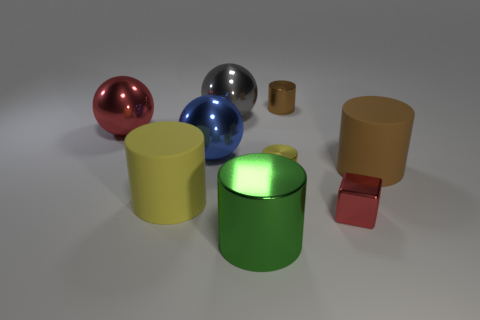Is there anything else that has the same shape as the tiny red metal object?
Provide a succinct answer. No. There is a brown matte object; is its size the same as the red metal thing on the right side of the big green shiny cylinder?
Keep it short and to the point. No. What number of large red balls have the same material as the green thing?
Your answer should be compact. 1. Does the gray object have the same size as the blue sphere?
Give a very brief answer. Yes. Is there any other thing that has the same color as the metal block?
Your response must be concise. Yes. What shape is the large object that is in front of the brown rubber object and behind the green cylinder?
Your answer should be compact. Cylinder. There is a brown cylinder that is behind the big red shiny ball; what is its size?
Keep it short and to the point. Small. There is a large object to the right of the red metallic object right of the large green metallic cylinder; what number of small yellow things are in front of it?
Offer a very short reply. 1. Are there any large yellow cylinders in front of the red metallic cube?
Provide a short and direct response. No. What number of other objects are the same size as the red sphere?
Give a very brief answer. 5. 